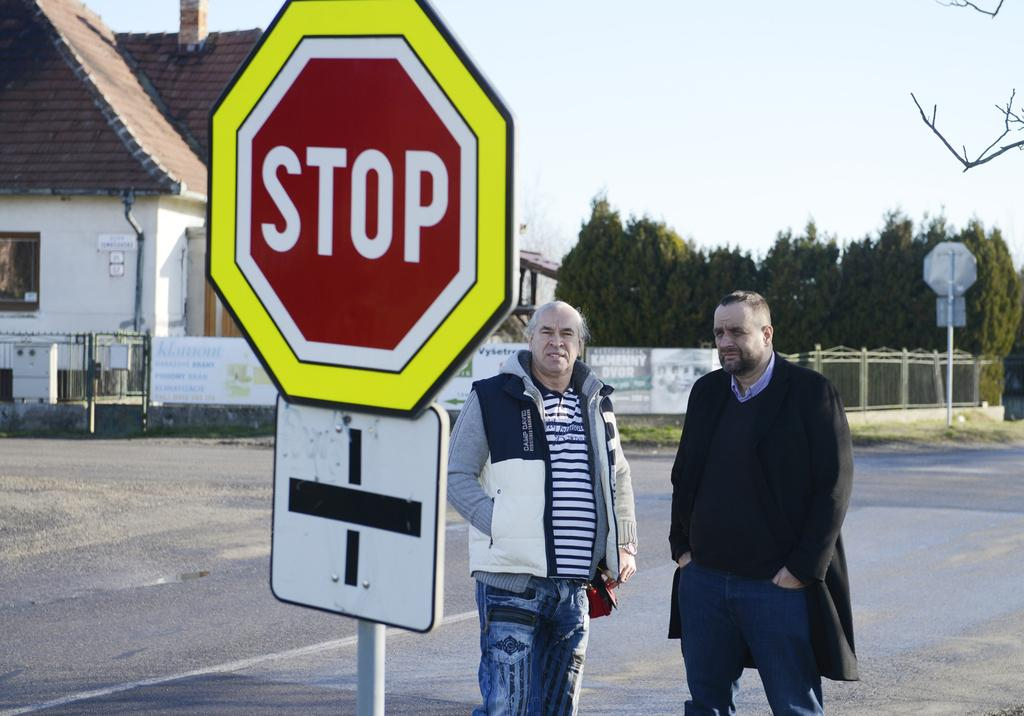<image>
Relay a brief, clear account of the picture shown. Two men are standing behind a stop sign that has a yellow border. 